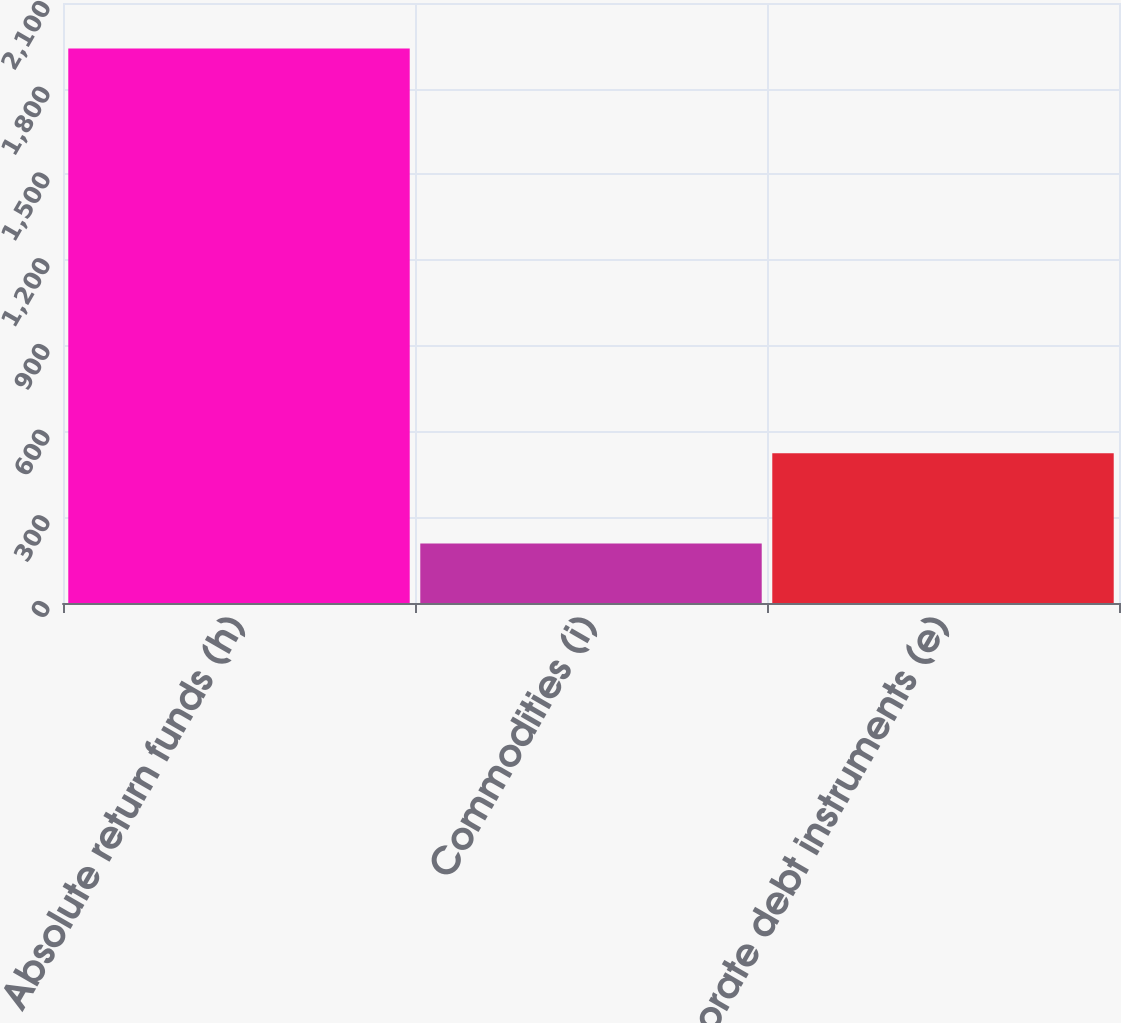<chart> <loc_0><loc_0><loc_500><loc_500><bar_chart><fcel>Absolute return funds (h)<fcel>Commodities (i)<fcel>Corporate debt instruments (e)<nl><fcel>1941<fcel>208<fcel>524<nl></chart> 